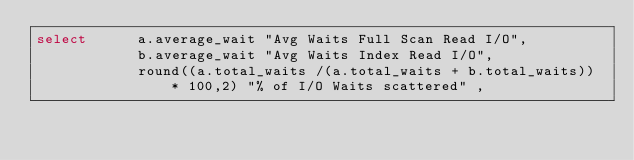<code> <loc_0><loc_0><loc_500><loc_500><_SQL_>select      a.average_wait "Avg Waits Full Scan Read I/O",
            b.average_wait "Avg Waits Index Read I/O",
            round((a.total_waits /(a.total_waits + b.total_waits)) * 100,2) "% of I/O Waits scattered" ,</code> 